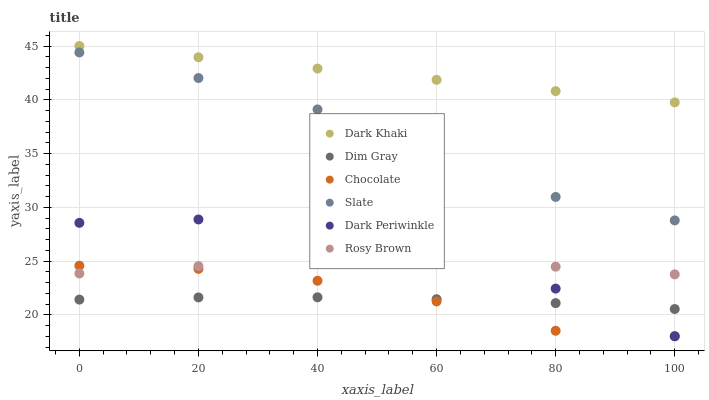Does Dim Gray have the minimum area under the curve?
Answer yes or no. Yes. Does Dark Khaki have the maximum area under the curve?
Answer yes or no. Yes. Does Slate have the minimum area under the curve?
Answer yes or no. No. Does Slate have the maximum area under the curve?
Answer yes or no. No. Is Dark Khaki the smoothest?
Answer yes or no. Yes. Is Slate the roughest?
Answer yes or no. Yes. Is Rosy Brown the smoothest?
Answer yes or no. No. Is Rosy Brown the roughest?
Answer yes or no. No. Does Chocolate have the lowest value?
Answer yes or no. Yes. Does Slate have the lowest value?
Answer yes or no. No. Does Dark Khaki have the highest value?
Answer yes or no. Yes. Does Slate have the highest value?
Answer yes or no. No. Is Dim Gray less than Slate?
Answer yes or no. Yes. Is Rosy Brown greater than Dim Gray?
Answer yes or no. Yes. Does Chocolate intersect Dim Gray?
Answer yes or no. Yes. Is Chocolate less than Dim Gray?
Answer yes or no. No. Is Chocolate greater than Dim Gray?
Answer yes or no. No. Does Dim Gray intersect Slate?
Answer yes or no. No. 